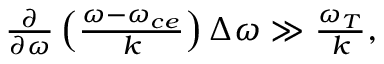Convert formula to latex. <formula><loc_0><loc_0><loc_500><loc_500>\begin{array} { r } { \frac { \partial } { \partial \omega } \left ( \frac { \omega - \omega _ { c e } } { k } \right ) \Delta \omega \gg \frac { \omega _ { T } } { k } , } \end{array}</formula> 